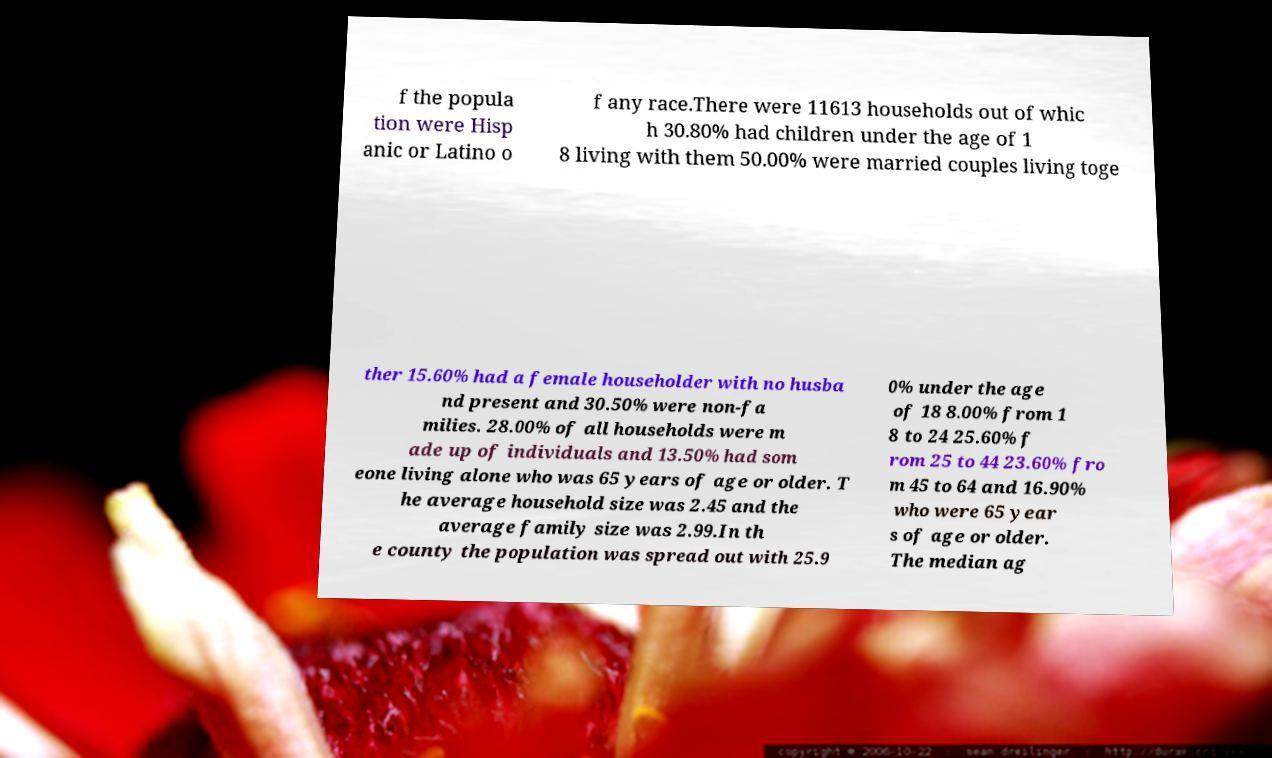Could you extract and type out the text from this image? f the popula tion were Hisp anic or Latino o f any race.There were 11613 households out of whic h 30.80% had children under the age of 1 8 living with them 50.00% were married couples living toge ther 15.60% had a female householder with no husba nd present and 30.50% were non-fa milies. 28.00% of all households were m ade up of individuals and 13.50% had som eone living alone who was 65 years of age or older. T he average household size was 2.45 and the average family size was 2.99.In th e county the population was spread out with 25.9 0% under the age of 18 8.00% from 1 8 to 24 25.60% f rom 25 to 44 23.60% fro m 45 to 64 and 16.90% who were 65 year s of age or older. The median ag 